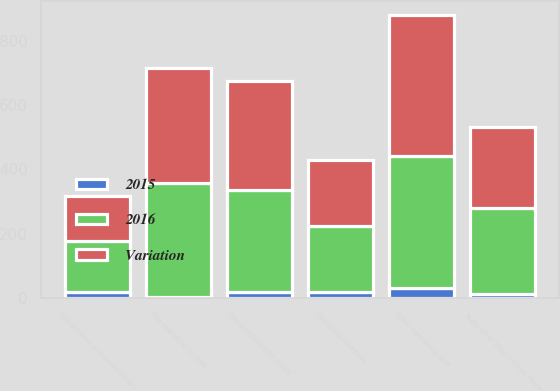Convert chart. <chart><loc_0><loc_0><loc_500><loc_500><stacked_bar_chart><ecel><fcel>Operating revenues<fcel>Gas purchased for resale<fcel>Other operations and<fcel>Depreciation and amortization<fcel>Taxes other than income taxes<fcel>Gas operating income<nl><fcel>2016<fcel>205.5<fcel>319<fcel>408<fcel>159<fcel>265<fcel>357<nl><fcel>Variation<fcel>205.5<fcel>337<fcel>440<fcel>142<fcel>252<fcel>356<nl><fcel>2015<fcel>19<fcel>18<fcel>32<fcel>17<fcel>13<fcel>1<nl></chart> 